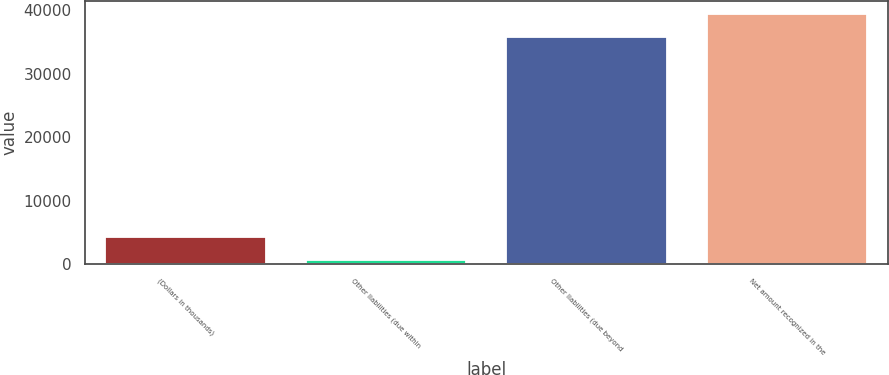Convert chart to OTSL. <chart><loc_0><loc_0><loc_500><loc_500><bar_chart><fcel>(Dollars in thousands)<fcel>Other liabilities (due within<fcel>Other liabilities (due beyond<fcel>Net amount recognized in the<nl><fcel>4225.7<fcel>639<fcel>35867<fcel>39453.7<nl></chart> 